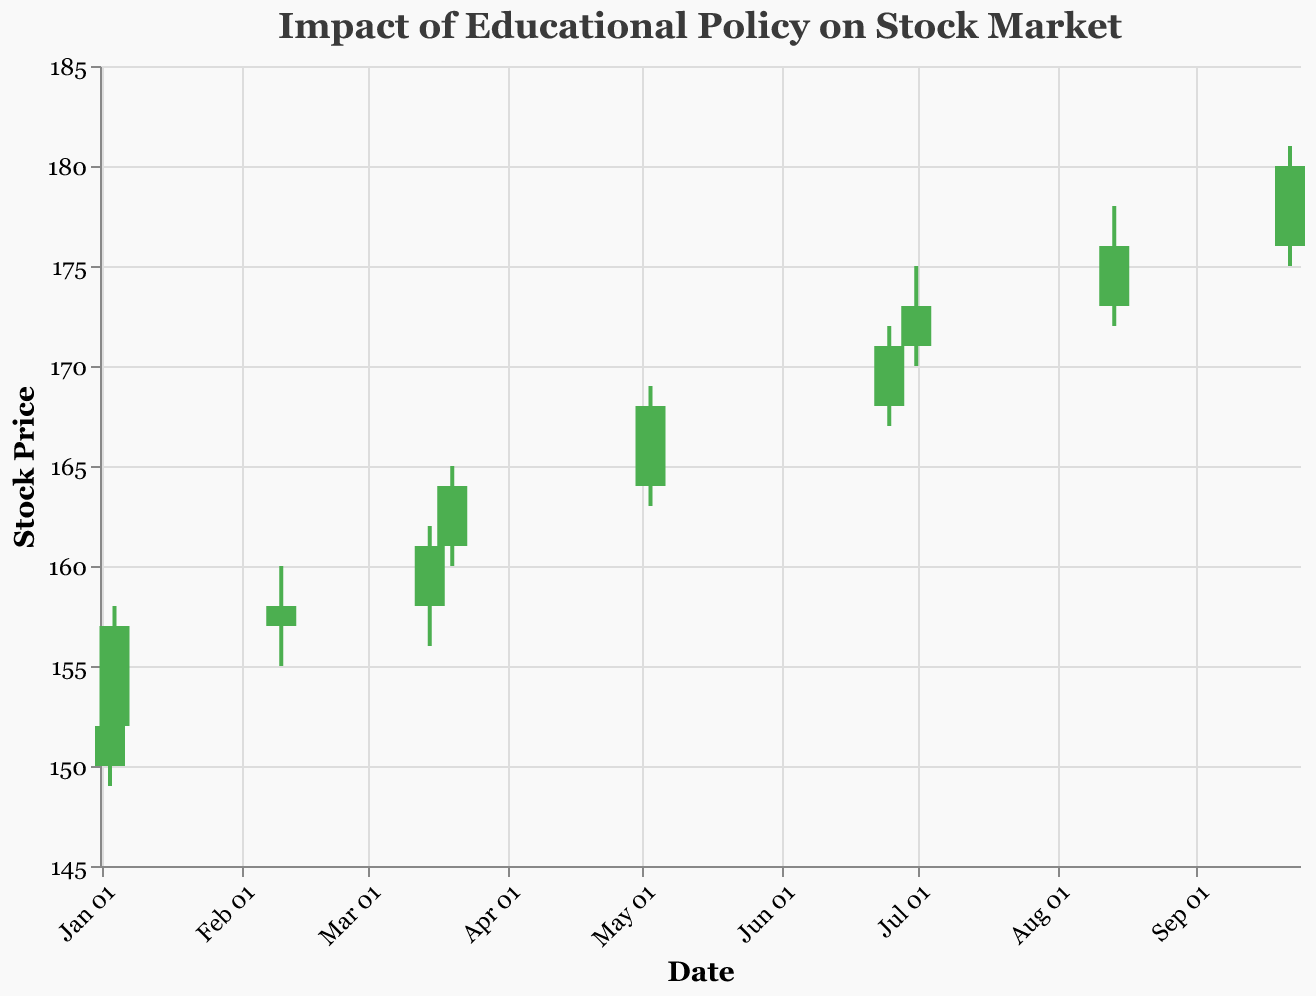How many data points are shown in the figure? There are 10 different dates listed in the data, each representing a point in the figure.
Answer: 10 What is the highest stock price reached in the plot? The highest stock price reached is the peak of the highest "High" value seen, which occurs on September 22, with a High of 181.00.
Answer: 181.00 Which policy announcement saw the largest relative increase in closing price compared to the opening price on the same day? To determine this, we calculate the difference between the Close and Open price for each policy event, then compare. The event "Expansion of Online Learning Grants" on January 4 had a significant increase (Close 157.00 - Open 152.00 = 5.00).
Answer: Expansion of Online Learning Grants What is the average closing stock price for the provided events? Summing up all Close values (152.00 + 157.00 + 158.00 + 161.00 + 164.00 + 168.00 + 171.00 + 173.00 + 176.00 + 180.00 = 1660.00) and dividing by the number of events (10) gives the average closing price.
Answer: 166.00 On which date did the "College Debt Cancellation Program" announcement take place, and what was the closing price? According to the data, the "College Debt Cancellation Program" took place on March 15. On that date, the closing price was 161.00.
Answer: March 15, 161.00 Compare the volume traded on days with the highest and lowest stock prices. How does it differ? The highest stock price was on September 22 with a volume of 1,450,000. The lowest stock price day is January 3 with a volume of 1,000,000. The difference is 1,450,000 - 1,000,000 = 450,000.
Answer: 450,000 Which policy announcement corresponds to the highest volume of trades? Reviewing the volumes, the highest occurs on September 22 with a volume of 1,450,000, during the policy announcement “Grants for Green Campus Projects.”
Answer: Grants for Green Campus Projects Which date experienced the smallest range between the high and low prices? To find the smallest range, calculate the difference between the High and Low for each date and compare. February 10 has the smallest difference (160.00 - 155.00 = 5.00).
Answer: February 10 Identify the policy announcement that caused the highest green candlestick (where Close > Open) in the figure. The highest green candlestick is determined by the difference between Close and Open for green days. The largest appears on January 4 (157.00 - 152.00 = 5.00) related to "Expansion of Online Learning Grants."
Answer: Expansion of Online Learning Grants What was the stock price trend during the summer of 2023 based on the policies mentioned? Looking at the dates from June 25 to September 22, the trend shows a steady increase in closing prices from 171.00 to 180.00, indicating a rising trend during this period.
Answer: Rising Trend 